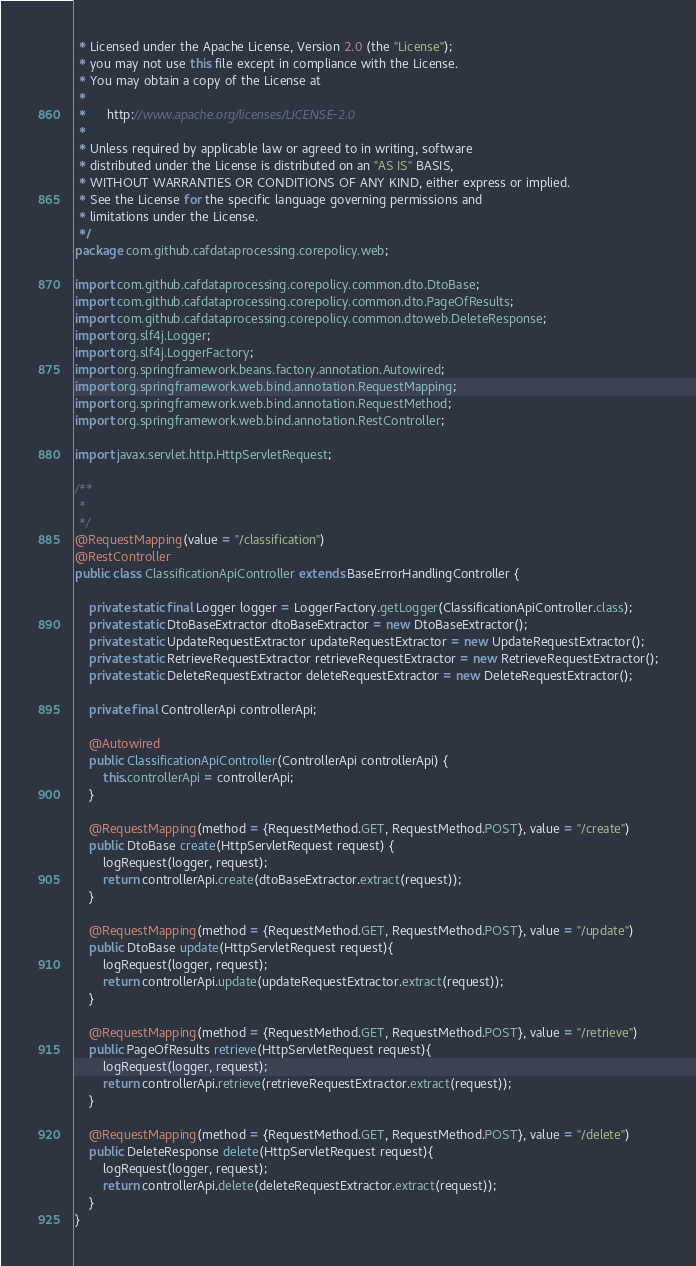Convert code to text. <code><loc_0><loc_0><loc_500><loc_500><_Java_> * Licensed under the Apache License, Version 2.0 (the "License");
 * you may not use this file except in compliance with the License.
 * You may obtain a copy of the License at
 *
 *      http://www.apache.org/licenses/LICENSE-2.0
 *
 * Unless required by applicable law or agreed to in writing, software
 * distributed under the License is distributed on an "AS IS" BASIS,
 * WITHOUT WARRANTIES OR CONDITIONS OF ANY KIND, either express or implied.
 * See the License for the specific language governing permissions and
 * limitations under the License.
 */
package com.github.cafdataprocessing.corepolicy.web;

import com.github.cafdataprocessing.corepolicy.common.dto.DtoBase;
import com.github.cafdataprocessing.corepolicy.common.dto.PageOfResults;
import com.github.cafdataprocessing.corepolicy.common.dtoweb.DeleteResponse;
import org.slf4j.Logger;
import org.slf4j.LoggerFactory;
import org.springframework.beans.factory.annotation.Autowired;
import org.springframework.web.bind.annotation.RequestMapping;
import org.springframework.web.bind.annotation.RequestMethod;
import org.springframework.web.bind.annotation.RestController;

import javax.servlet.http.HttpServletRequest;

/**
 *
 */
@RequestMapping(value = "/classification")
@RestController
public class ClassificationApiController extends BaseErrorHandlingController {

    private static final Logger logger = LoggerFactory.getLogger(ClassificationApiController.class);
    private static DtoBaseExtractor dtoBaseExtractor = new DtoBaseExtractor();
    private static UpdateRequestExtractor updateRequestExtractor = new UpdateRequestExtractor();
    private static RetrieveRequestExtractor retrieveRequestExtractor = new RetrieveRequestExtractor();
    private static DeleteRequestExtractor deleteRequestExtractor = new DeleteRequestExtractor();

    private final ControllerApi controllerApi;

    @Autowired
    public ClassificationApiController(ControllerApi controllerApi) {
        this.controllerApi = controllerApi;
    }

    @RequestMapping(method = {RequestMethod.GET, RequestMethod.POST}, value = "/create")
    public DtoBase create(HttpServletRequest request) {
        logRequest(logger, request);
        return controllerApi.create(dtoBaseExtractor.extract(request));
    }

    @RequestMapping(method = {RequestMethod.GET, RequestMethod.POST}, value = "/update")
    public DtoBase update(HttpServletRequest request){
        logRequest(logger, request);
        return controllerApi.update(updateRequestExtractor.extract(request));
    }

    @RequestMapping(method = {RequestMethod.GET, RequestMethod.POST}, value = "/retrieve")
    public PageOfResults retrieve(HttpServletRequest request){
        logRequest(logger, request);
        return controllerApi.retrieve(retrieveRequestExtractor.extract(request));
    }

    @RequestMapping(method = {RequestMethod.GET, RequestMethod.POST}, value = "/delete")
    public DeleteResponse delete(HttpServletRequest request){
        logRequest(logger, request);
        return controllerApi.delete(deleteRequestExtractor.extract(request));
    }
}
</code> 